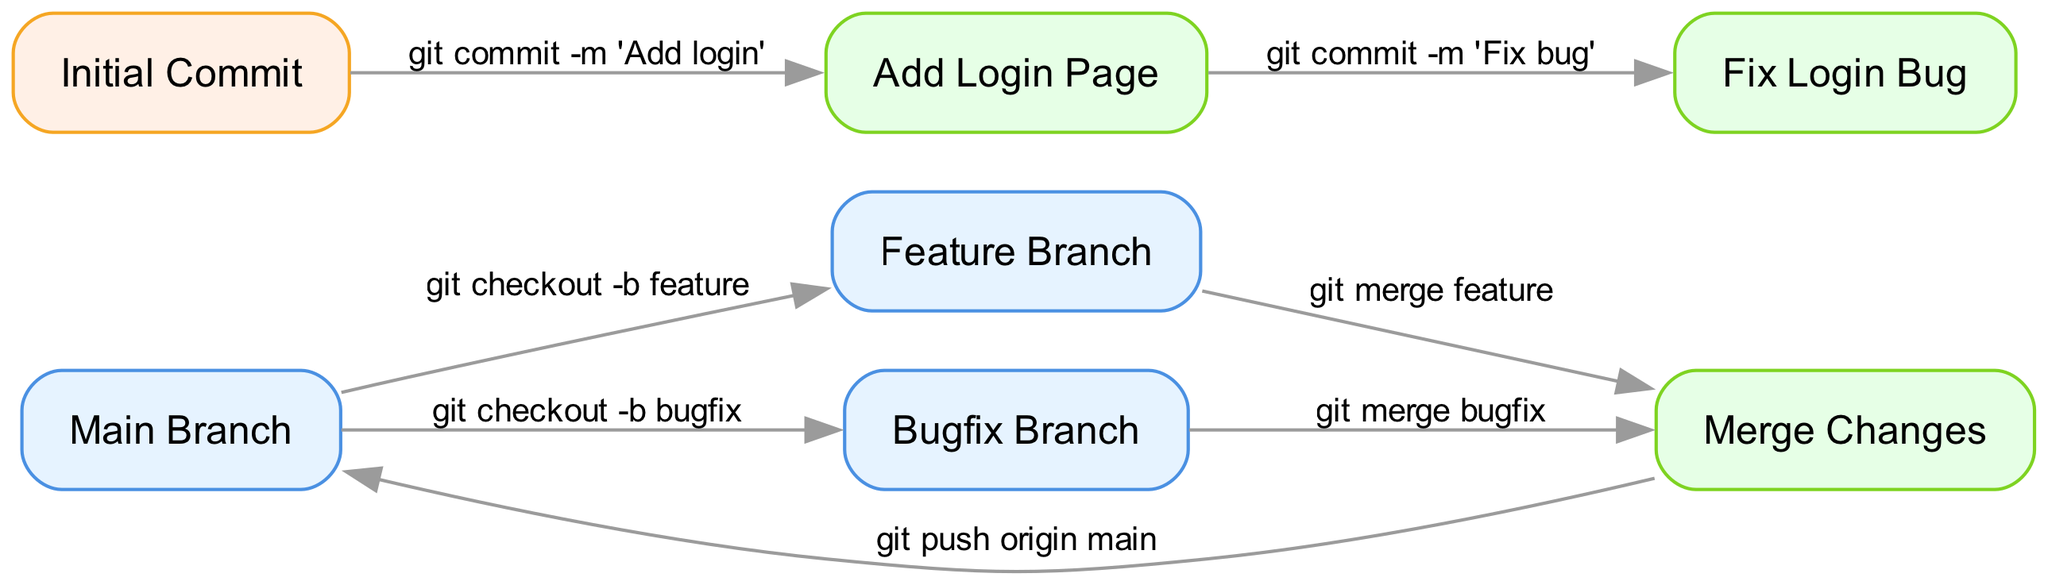What is the label of the initial commit node? The label of the node representing the initial commit is explicitly provided in the diagram data. By locating the node with the id "commit1", we can see that its label is "Initial Commit".
Answer: Initial Commit How many branches are visible in the diagram? By examining the nodes section of the diagram, we can identify that there are three branches listed: "Main Branch", "Feature Branch", and "Bugfix Branch". Counting these yields a total of three branches.
Answer: 3 What command is used to merge changes from the feature branch? The edges in the diagram indicate the command used to merge changes from the feature branch to the main branch. From the "feature" node to the "merge" node, the label specifies "git merge feature".
Answer: git merge feature Which node represents the bugfix changes? The node that specifically represents bugfix changes in the diagram can be found by looking for the node labeled "Bugfix Branch". This directly provides the required identifier of this node.
Answer: Bugfix Branch What is the final action performed in the diagram? The final action represented in the flow of the diagram can be traced by following the edges from the "merge" node. The edge to the "main" node has the label "git push origin main", which indicates this is the last action.
Answer: git push origin main How many edges connect the merge node to other nodes? To determine the number of edges connected to the "merge" node, we refer to the edges in the diagram. There are two edges - one leading to "main" and one each from "feature" and "bugfix". So, the merge node is connected by two edges.
Answer: 2 What is the relationship between the initial commit and the add login page commit? The relationship can be traced through the edges in the diagram. The edge from the "commit1" node (Initial Commit) to the "commit2" node (Add Login Page) shows that one commit follows another with the label indicating the action taken.
Answer: Add Login Page What type of branch is connected to the bugfix changes? By referring to the edges related to the "bugfix" node, we see that it leads to the "merge" node. This clearly shows the relationship, indicating it is a bugfix type branch in the context of the diagram.
Answer: Bugfix Branch 